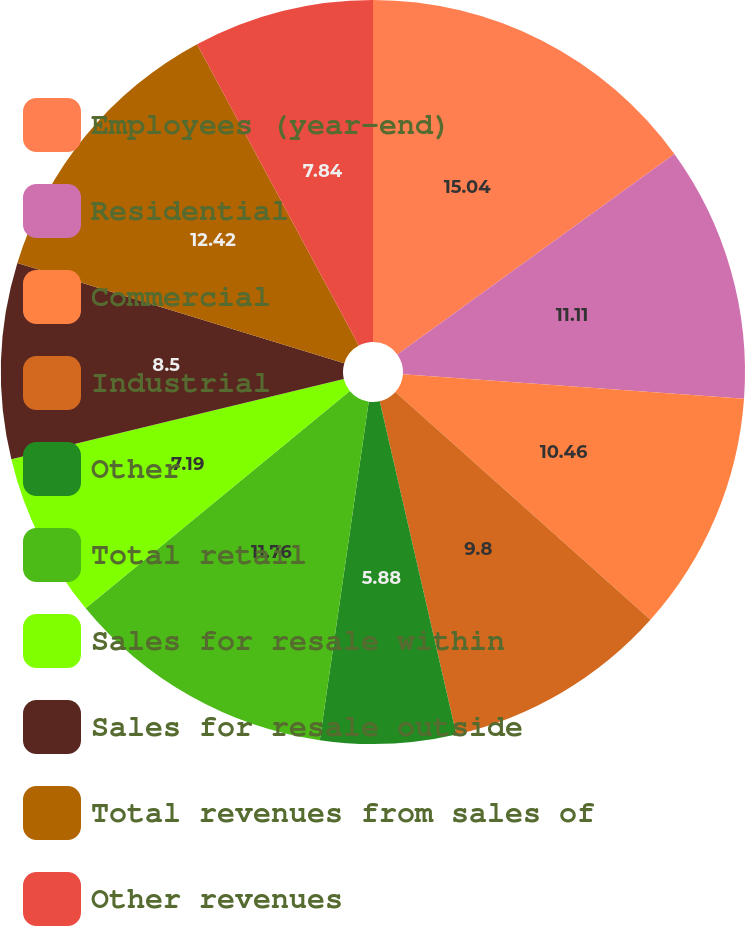Convert chart to OTSL. <chart><loc_0><loc_0><loc_500><loc_500><pie_chart><fcel>Employees (year-end)<fcel>Residential<fcel>Commercial<fcel>Industrial<fcel>Other<fcel>Total retail<fcel>Sales for resale within<fcel>Sales for resale outside<fcel>Total revenues from sales of<fcel>Other revenues<nl><fcel>15.03%<fcel>11.11%<fcel>10.46%<fcel>9.8%<fcel>5.88%<fcel>11.76%<fcel>7.19%<fcel>8.5%<fcel>12.42%<fcel>7.84%<nl></chart> 